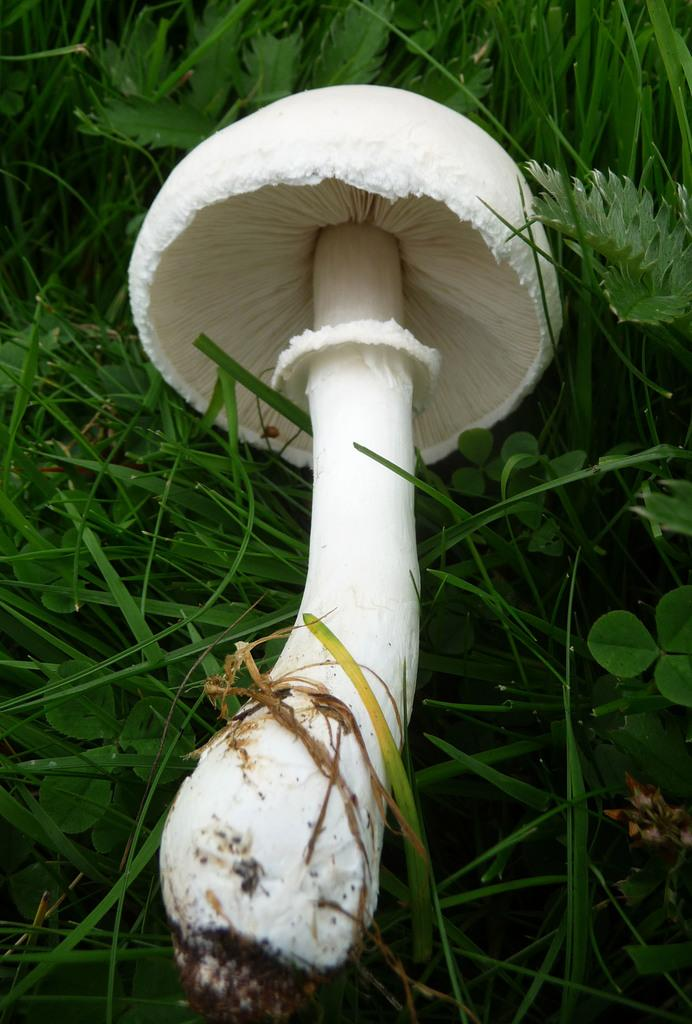What is the main subject in the center of the image? There is a mushroom in the center of the image. What type of vegetation is present at the top of the image? There are leaves at the top of the image. What type of ground cover is present in the center of the image? There is grass in the center of the image. What type of ice can be seen melting in the image? There is no ice present in the image; it features a mushroom, leaves, and grass. 